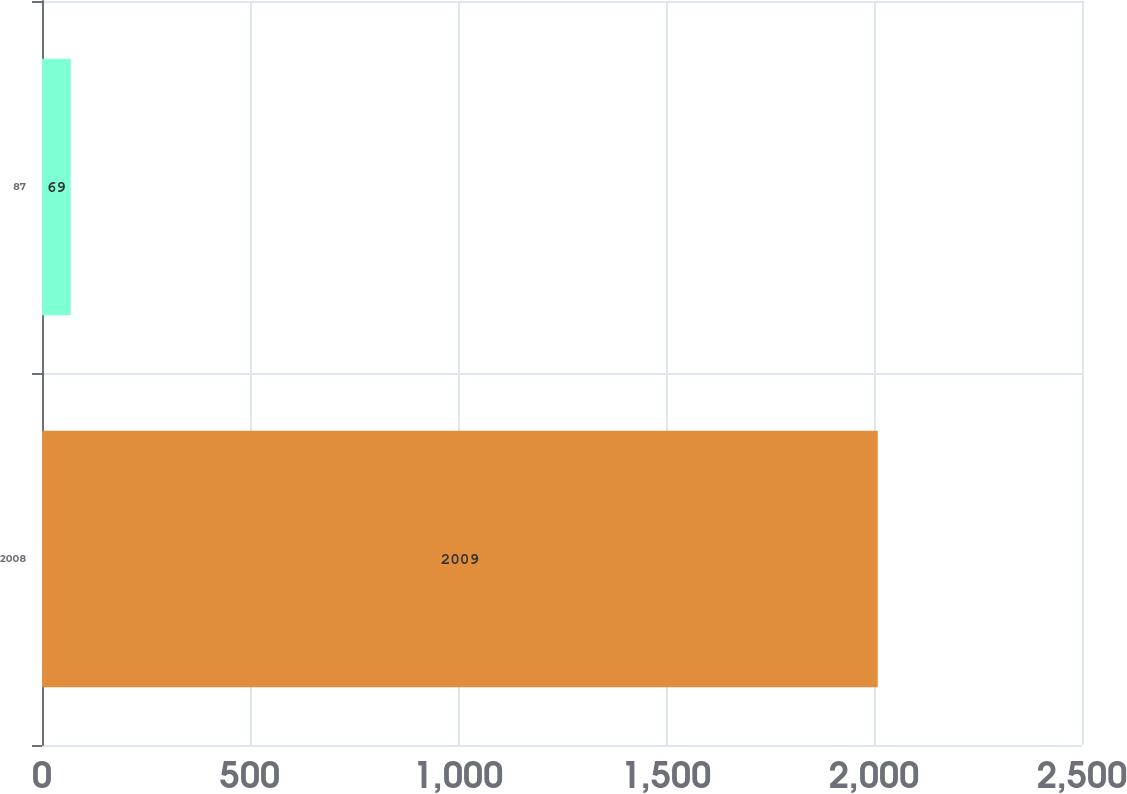Convert chart. <chart><loc_0><loc_0><loc_500><loc_500><bar_chart><fcel>2008<fcel>87<nl><fcel>2009<fcel>69<nl></chart> 